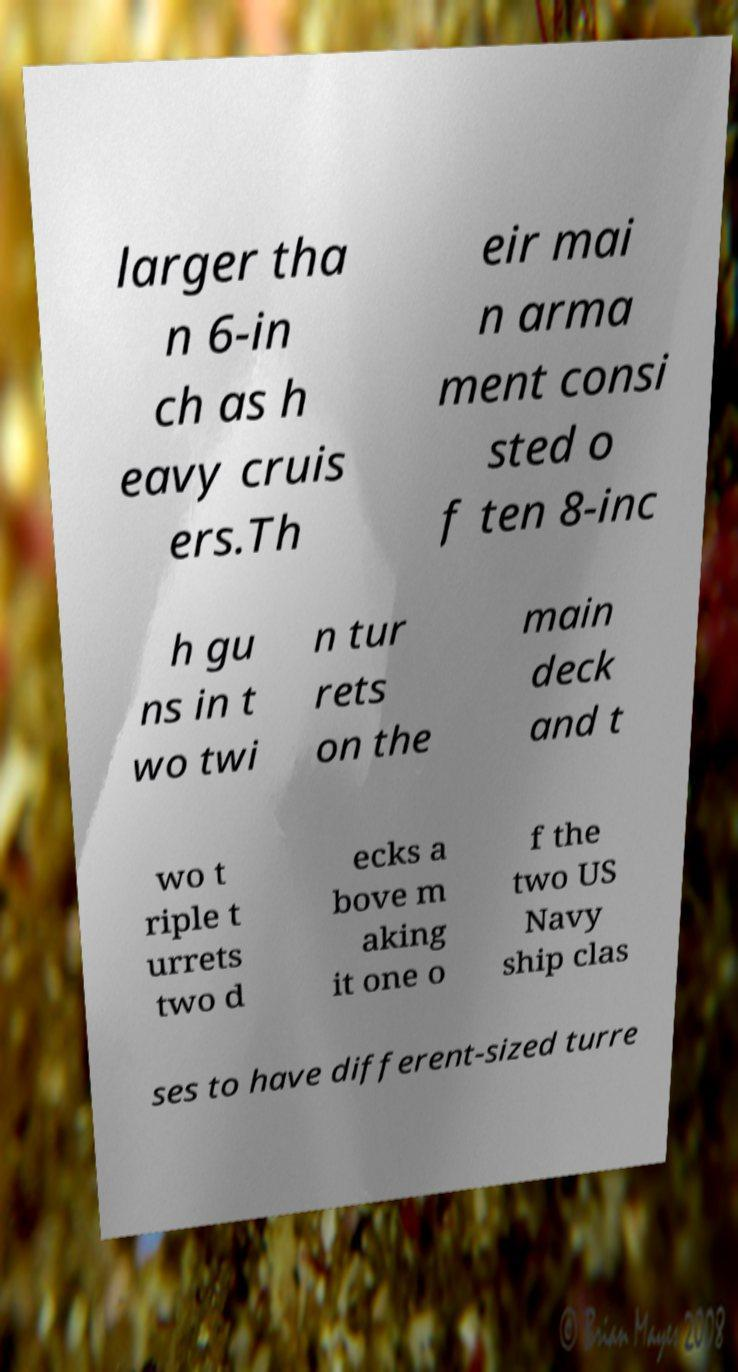For documentation purposes, I need the text within this image transcribed. Could you provide that? larger tha n 6-in ch as h eavy cruis ers.Th eir mai n arma ment consi sted o f ten 8-inc h gu ns in t wo twi n tur rets on the main deck and t wo t riple t urrets two d ecks a bove m aking it one o f the two US Navy ship clas ses to have different-sized turre 